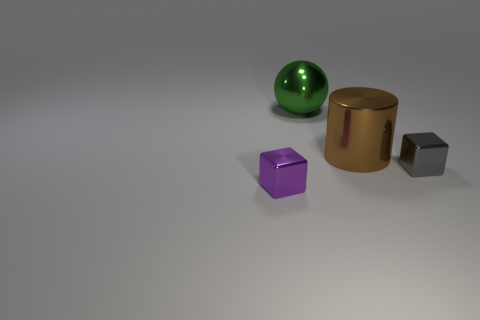Add 2 gray metal objects. How many objects exist? 6 Subtract all spheres. How many objects are left? 3 Add 1 small green metal cylinders. How many small green metal cylinders exist? 1 Subtract 0 cyan cubes. How many objects are left? 4 Subtract all large green metal objects. Subtract all purple things. How many objects are left? 2 Add 2 small gray shiny objects. How many small gray shiny objects are left? 3 